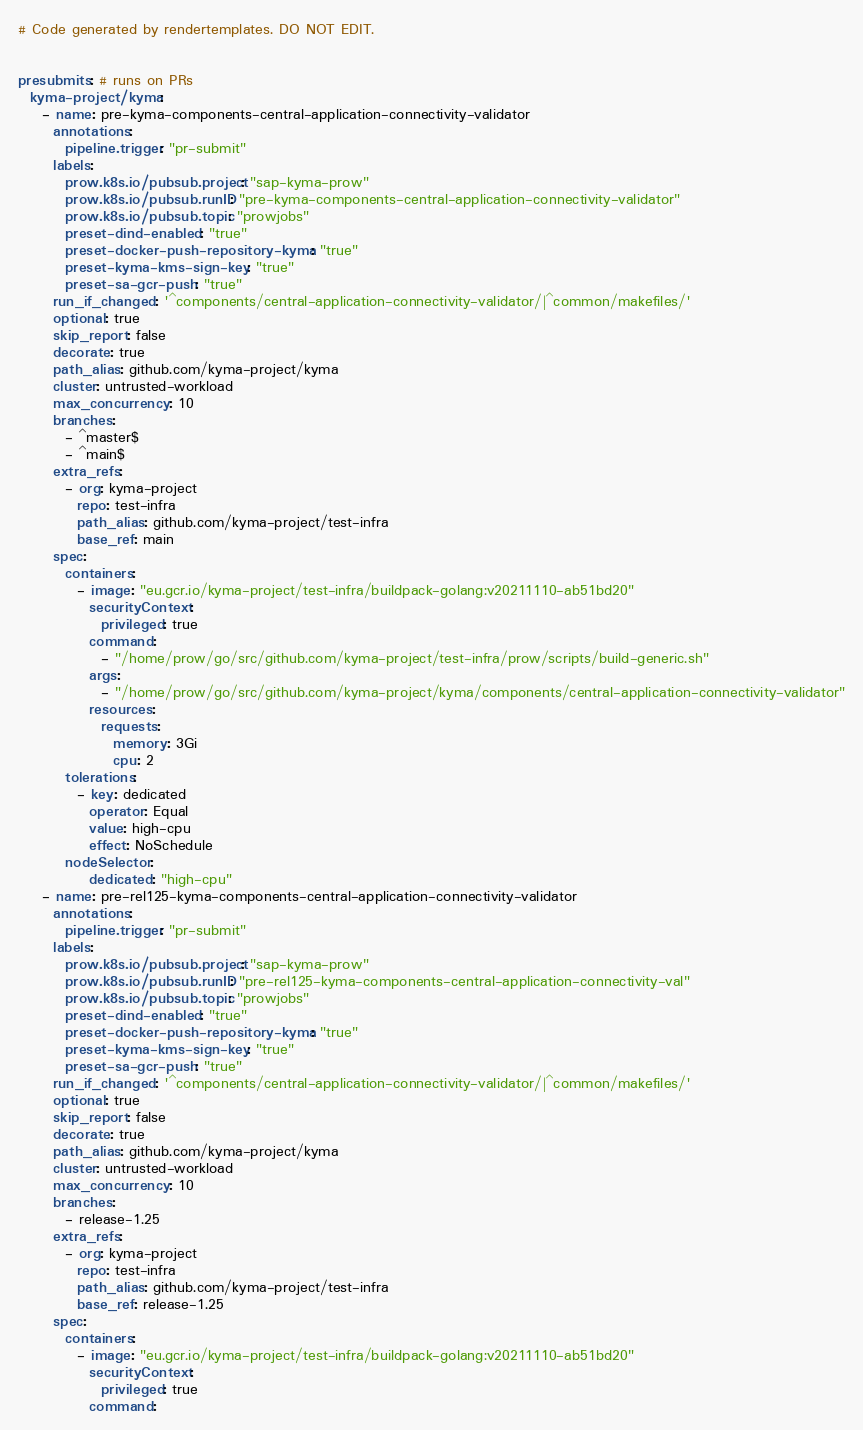Convert code to text. <code><loc_0><loc_0><loc_500><loc_500><_YAML_># Code generated by rendertemplates. DO NOT EDIT.


presubmits: # runs on PRs
  kyma-project/kyma:
    - name: pre-kyma-components-central-application-connectivity-validator
      annotations:
        pipeline.trigger: "pr-submit"
      labels:
        prow.k8s.io/pubsub.project: "sap-kyma-prow"
        prow.k8s.io/pubsub.runID: "pre-kyma-components-central-application-connectivity-validator"
        prow.k8s.io/pubsub.topic: "prowjobs"
        preset-dind-enabled: "true"
        preset-docker-push-repository-kyma: "true"
        preset-kyma-kms-sign-key: "true"
        preset-sa-gcr-push: "true"
      run_if_changed: '^components/central-application-connectivity-validator/|^common/makefiles/'
      optional: true
      skip_report: false
      decorate: true
      path_alias: github.com/kyma-project/kyma
      cluster: untrusted-workload
      max_concurrency: 10
      branches:
        - ^master$
        - ^main$
      extra_refs:
        - org: kyma-project
          repo: test-infra
          path_alias: github.com/kyma-project/test-infra
          base_ref: main
      spec:
        containers:
          - image: "eu.gcr.io/kyma-project/test-infra/buildpack-golang:v20211110-ab51bd20"
            securityContext:
              privileged: true
            command:
              - "/home/prow/go/src/github.com/kyma-project/test-infra/prow/scripts/build-generic.sh"
            args:
              - "/home/prow/go/src/github.com/kyma-project/kyma/components/central-application-connectivity-validator"
            resources:
              requests:
                memory: 3Gi
                cpu: 2
        tolerations:
          - key: dedicated
            operator: Equal
            value: high-cpu
            effect: NoSchedule
        nodeSelector:
            dedicated: "high-cpu"
    - name: pre-rel125-kyma-components-central-application-connectivity-validator
      annotations:
        pipeline.trigger: "pr-submit"
      labels:
        prow.k8s.io/pubsub.project: "sap-kyma-prow"
        prow.k8s.io/pubsub.runID: "pre-rel125-kyma-components-central-application-connectivity-val"
        prow.k8s.io/pubsub.topic: "prowjobs"
        preset-dind-enabled: "true"
        preset-docker-push-repository-kyma: "true"
        preset-kyma-kms-sign-key: "true"
        preset-sa-gcr-push: "true"
      run_if_changed: '^components/central-application-connectivity-validator/|^common/makefiles/'
      optional: true
      skip_report: false
      decorate: true
      path_alias: github.com/kyma-project/kyma
      cluster: untrusted-workload
      max_concurrency: 10
      branches:
        - release-1.25
      extra_refs:
        - org: kyma-project
          repo: test-infra
          path_alias: github.com/kyma-project/test-infra
          base_ref: release-1.25
      spec:
        containers:
          - image: "eu.gcr.io/kyma-project/test-infra/buildpack-golang:v20211110-ab51bd20"
            securityContext:
              privileged: true
            command:</code> 